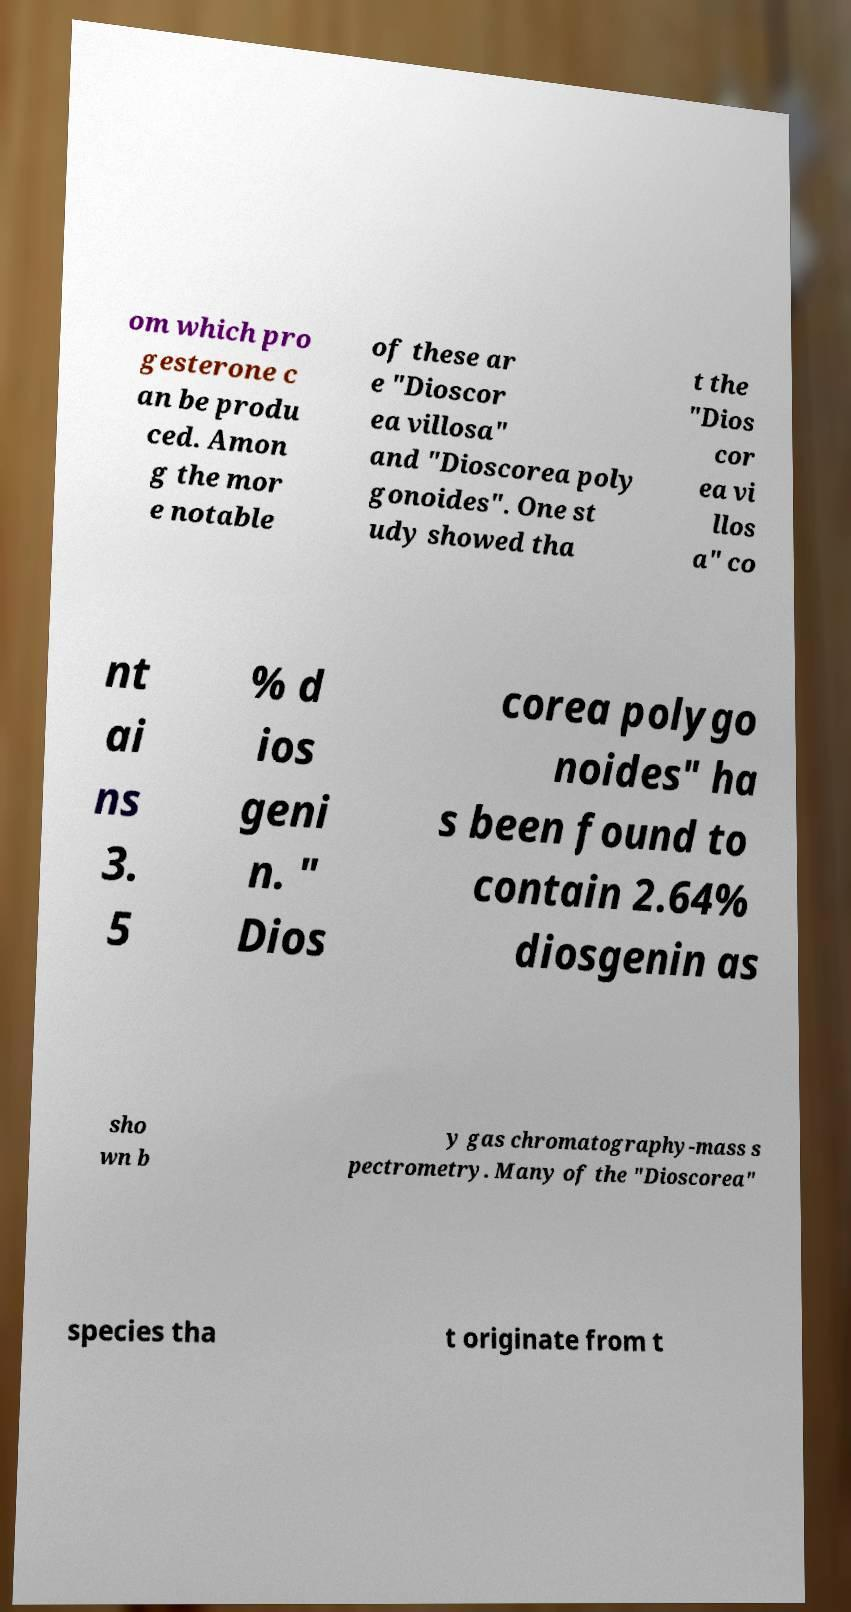Please identify and transcribe the text found in this image. om which pro gesterone c an be produ ced. Amon g the mor e notable of these ar e "Dioscor ea villosa" and "Dioscorea poly gonoides". One st udy showed tha t the "Dios cor ea vi llos a" co nt ai ns 3. 5 % d ios geni n. " Dios corea polygo noides" ha s been found to contain 2.64% diosgenin as sho wn b y gas chromatography-mass s pectrometry. Many of the "Dioscorea" species tha t originate from t 